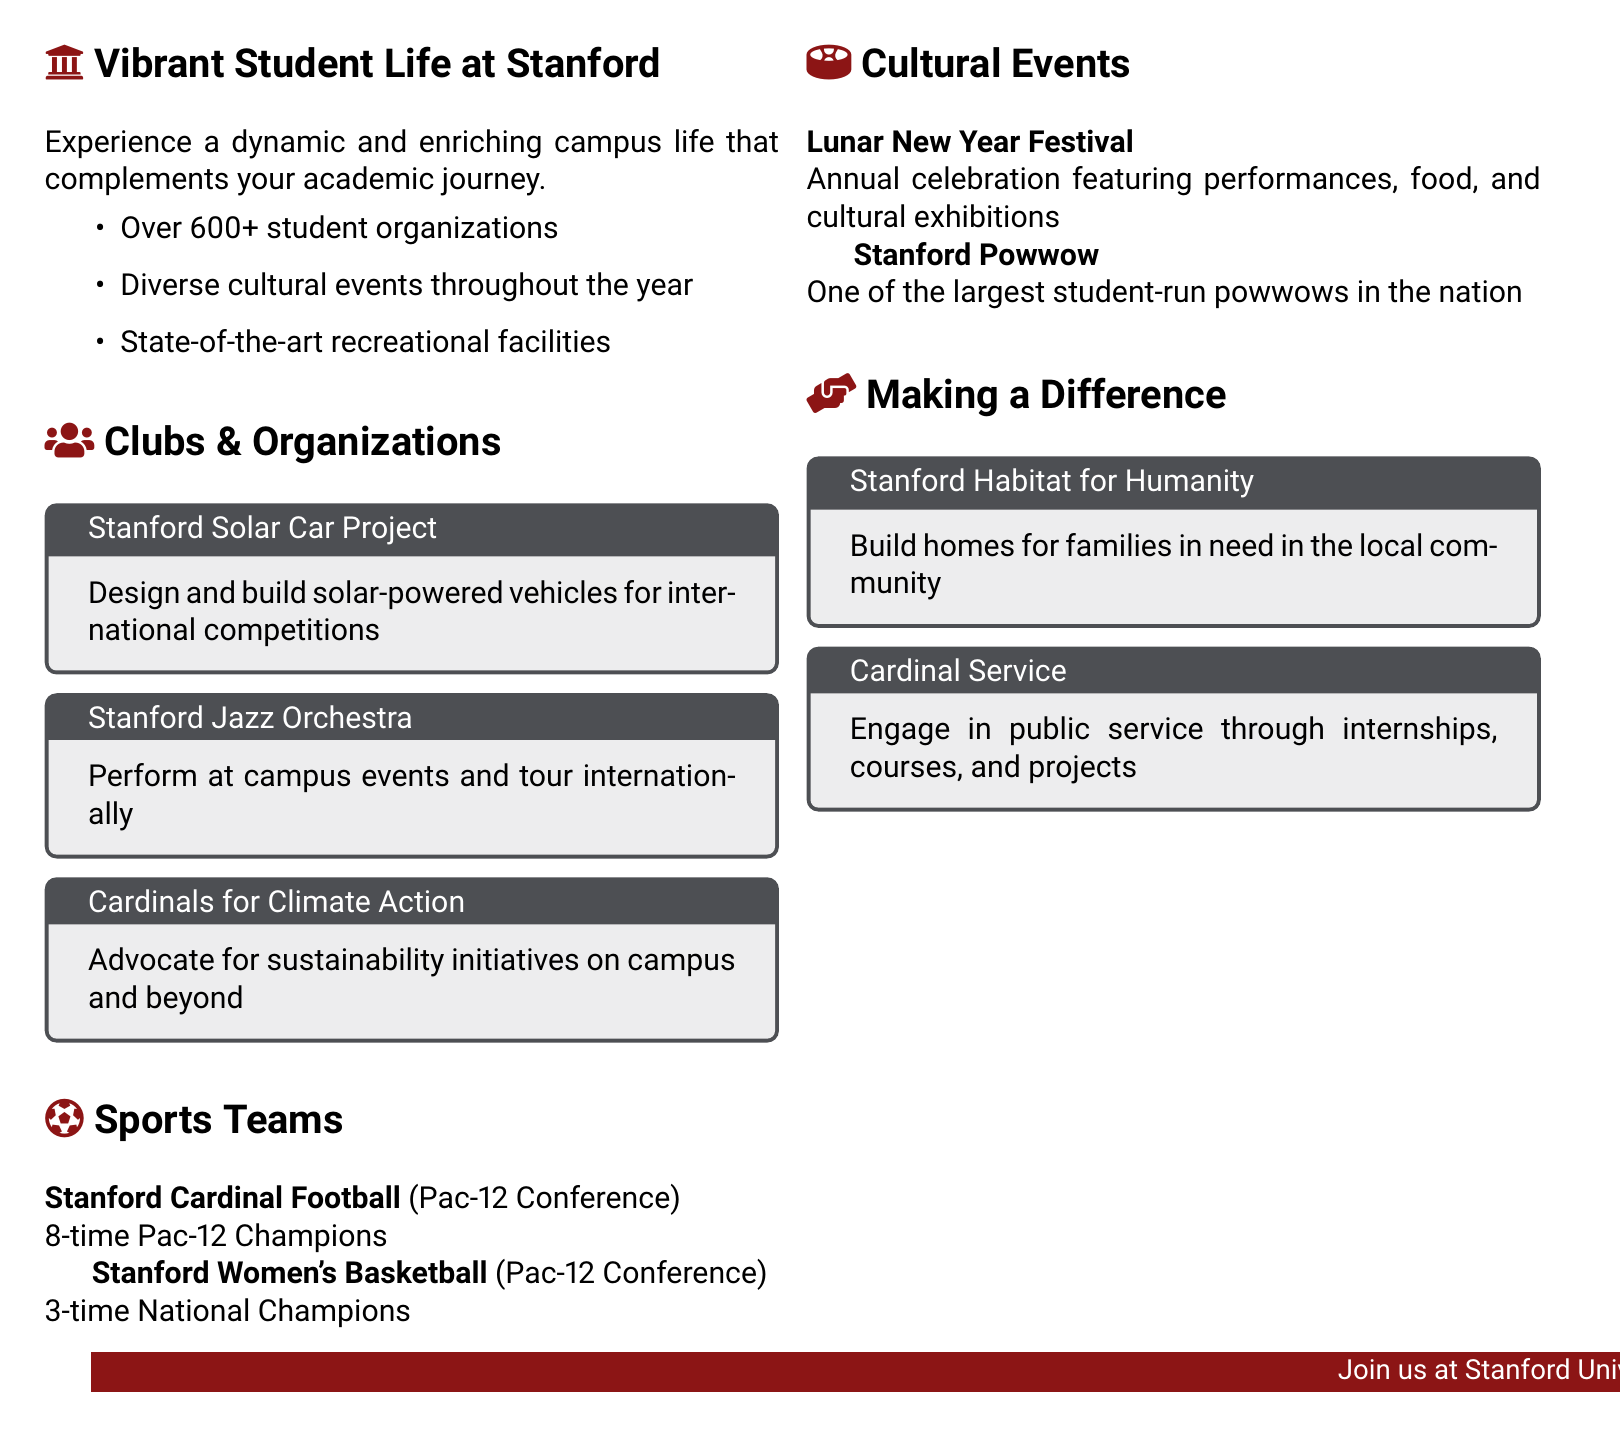What is the total number of student organizations? The document states that there are over 600 student organizations at Stanford.
Answer: 600+ What sport is Stanford a champion in multiple times? The document mentions that Stanford Women's Basketball is a three-time national champion.
Answer: Women's Basketball What is the name of the student organization focused on sustainability? The document lists "Cardinals for Climate Action" as an organization advocating for sustainability.
Answer: Cardinals for Climate Action How many times has Stanford Cardinal Football been a Pac-12 champion? The document states that Stanford Cardinal Football has won the Pac-12 Championship 8 times.
Answer: 8 times What major cultural event celebrates the Lunar New Year? The document mentions the "Lunar New Year Festival" as an annual celebration.
Answer: Lunar New Year Festival What initiative involves building homes for families in need? The document describes "Stanford Habitat for Humanity" as an initiative that builds homes for families.
Answer: Stanford Habitat for Humanity What is the purpose of the "Cardinal Service"? The document indicates that "Cardinal Service" engages students in public service through various activities.
Answer: Public service Which event is one of the largest student-run powwows in the nation? The document highlights the "Stanford Powwow" as one of the largest student-run powwows.
Answer: Stanford Powwow Which organization designs solar-powered vehicles? The document features the "Stanford Solar Car Project" as the organization that designs solar vehicles.
Answer: Stanford Solar Car Project 